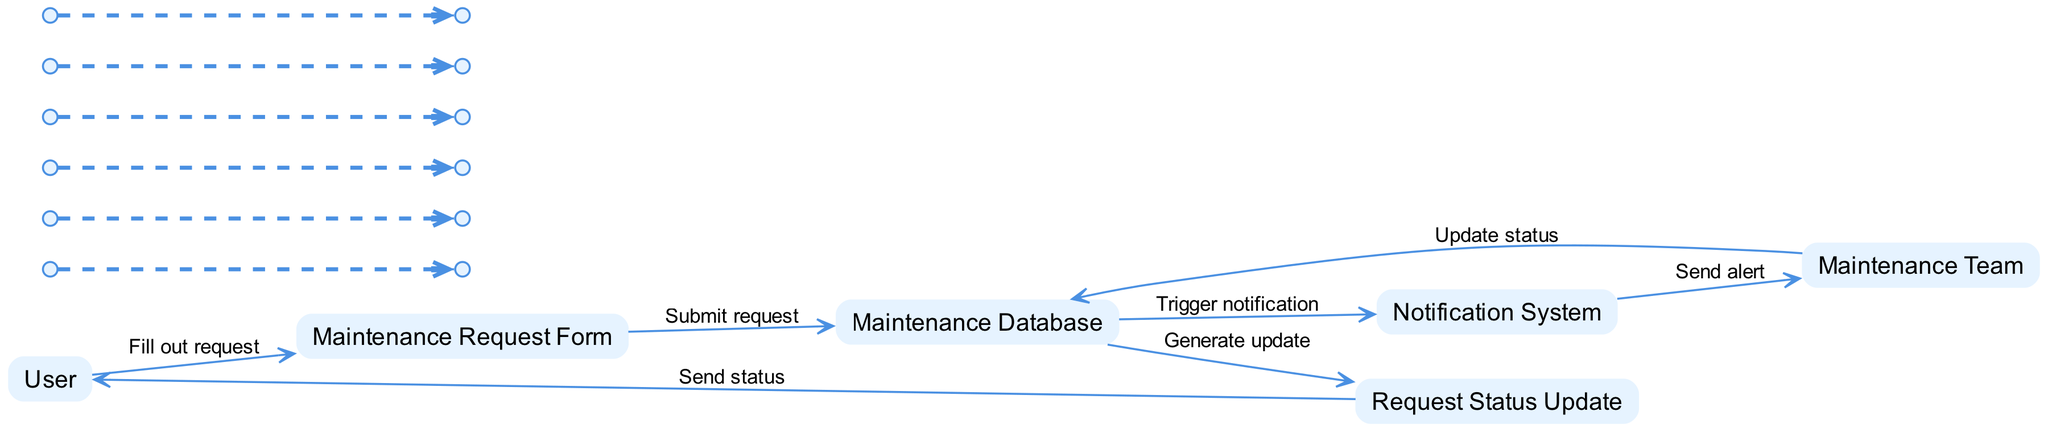What is the first action taken by the User? The User's first action in the diagram is to fill out the maintenance request form. This is indicated by the edge drawn from the User to the Maintenance Request Form, labeled "Fill out request."
Answer: Fill out request How many main actors are there in the diagram? There are two main actors depicted in the diagram: User and Maintenance Team. These can be identified as the elements categorized as "Actor."
Answer: Two Which system is responsible for logging maintenance requests? The system responsible for logging maintenance requests is the Maintenance Database. This is represented by the node labeled "Maintenance Database" in the diagram.
Answer: Maintenance Database What does the Maintenance Database trigger after submission? After a request is submitted to the Maintenance Database, it triggers the Notification System. This action is specified by the edge labeled "Trigger notification" from the Maintenance Database to the Notification System.
Answer: Trigger notification What is sent to the User at the end of the process? At the end of the process, a request status update is sent back to the User. This is represented by the edge from Request Status Update to User, labeled "Send status."
Answer: Send status What role does the Notification System play in the process? The Notification System sends alerts about new requests to the Maintenance Team. This relationship is depicted in the diagram by the edge labeled "Send alert" from the Notification System to the Maintenance Team.
Answer: Send alert What type of object is the Maintenance Request Form? The Maintenance Request Form is classified as an "Object." This classification is noted in the description of the element in the diagram.
Answer: Object How does the Maintenance Team know that there is a new request? The Maintenance Team knows there is a new request through an alert sent by the Notification System, triggered by the Maintenance Database. This can be traced through the labeled connections in the diagram indicating the notification process.
Answer: Through alert What is the final output of the sequence? The final output of the sequence is the status update sent to the User. This is labeled as the last action between the Request Status Update and User in the diagram.
Answer: Status update 